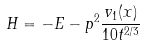Convert formula to latex. <formula><loc_0><loc_0><loc_500><loc_500>H = - E - p ^ { 2 } \frac { v _ { 1 } ( x ) } { 1 0 t ^ { 2 / 3 } }</formula> 